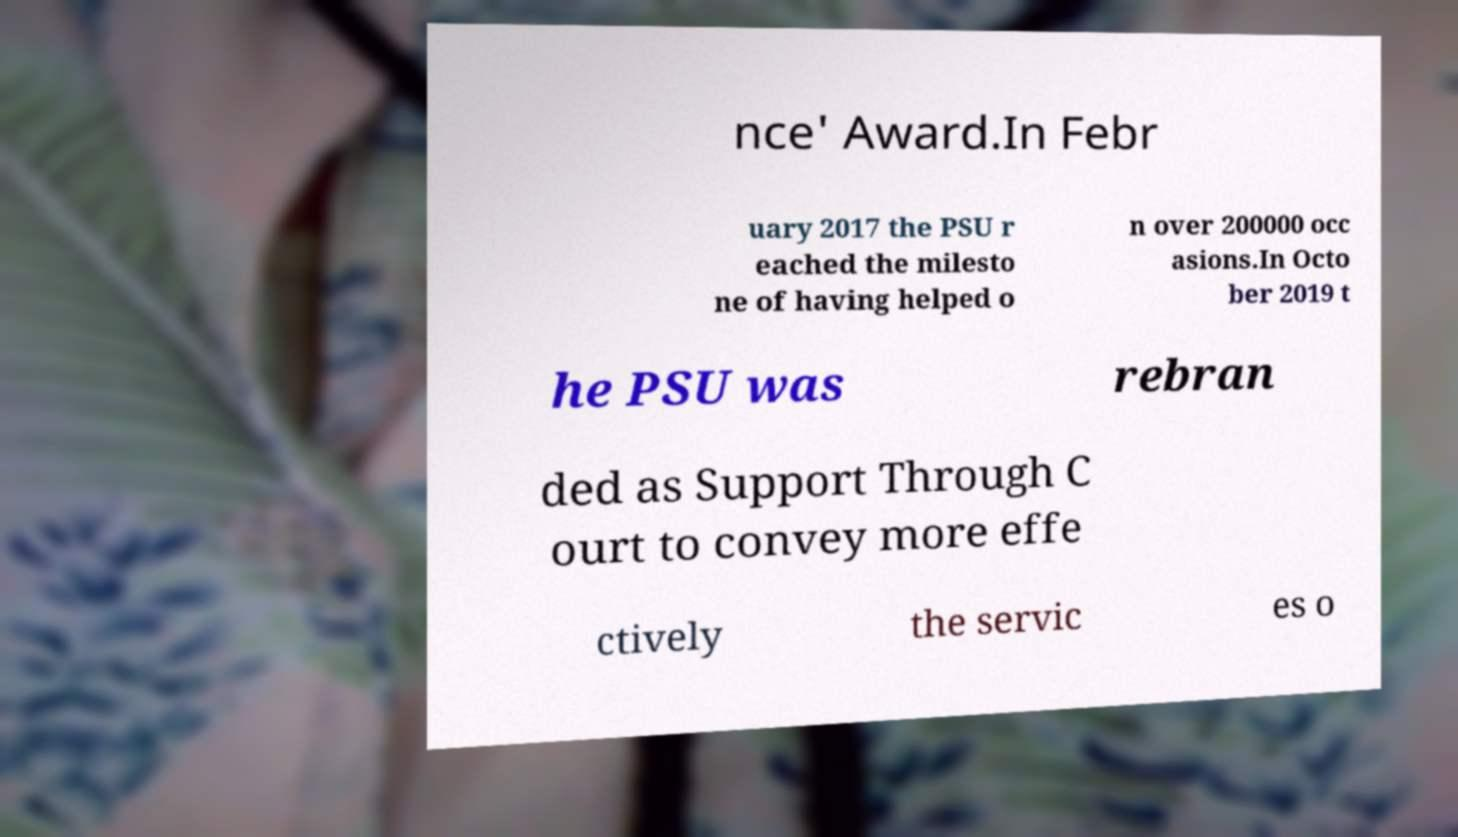Can you read and provide the text displayed in the image?This photo seems to have some interesting text. Can you extract and type it out for me? nce' Award.In Febr uary 2017 the PSU r eached the milesto ne of having helped o n over 200000 occ asions.In Octo ber 2019 t he PSU was rebran ded as Support Through C ourt to convey more effe ctively the servic es o 